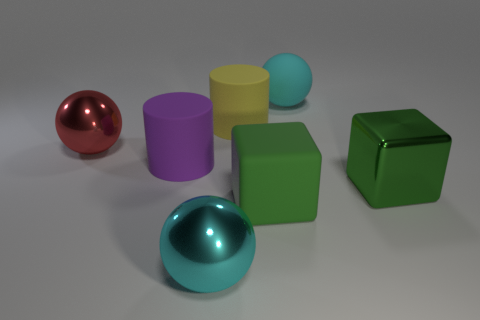What size is the shiny sphere that is the same color as the rubber sphere?
Provide a succinct answer. Large. Is the yellow cylinder made of the same material as the large sphere to the left of the big purple cylinder?
Provide a succinct answer. No. The cyan thing in front of the green matte block has what shape?
Offer a very short reply. Sphere. What number of other things are there of the same material as the large purple cylinder
Make the answer very short. 3. How big is the purple thing?
Your response must be concise. Large. How many other objects are the same color as the big matte cube?
Give a very brief answer. 1. There is a big thing that is behind the big purple object and on the left side of the big cyan metal thing; what is its color?
Your response must be concise. Red. How many small green metal cylinders are there?
Offer a terse response. 0. Do the large red object and the yellow cylinder have the same material?
Ensure brevity in your answer.  No. What shape is the big matte object that is in front of the large block right of the cyan object that is behind the purple rubber thing?
Ensure brevity in your answer.  Cube. 